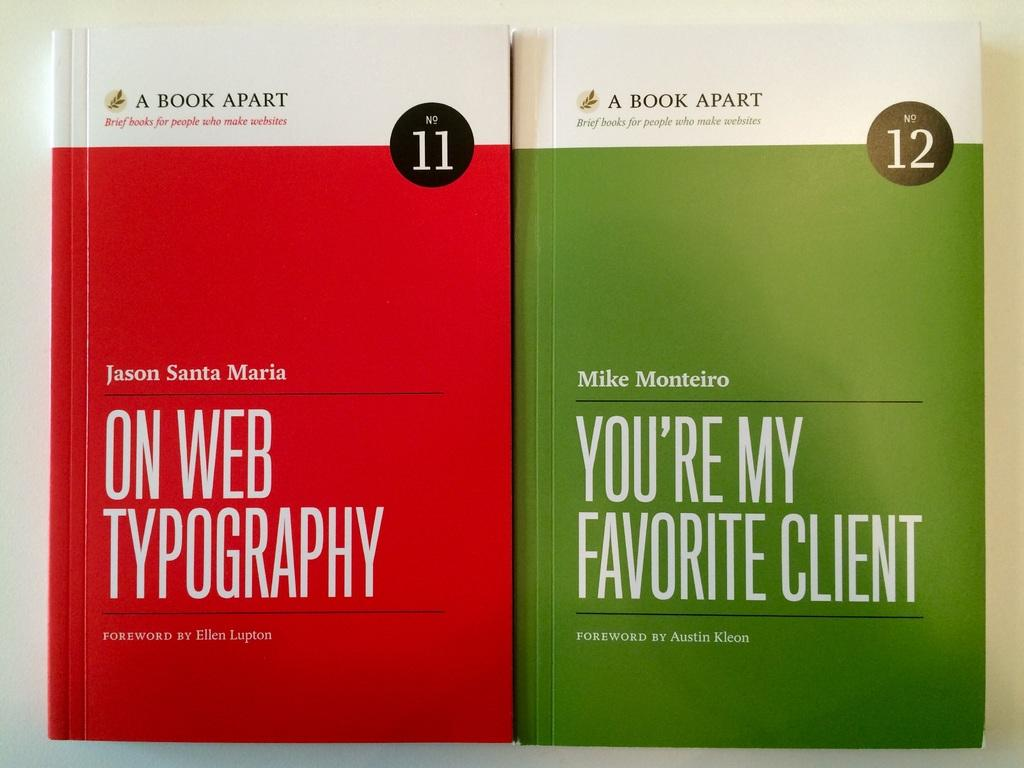<image>
Relay a brief, clear account of the picture shown. Jason Santa Maria On web typography book and you're my favorite client book by Mike Monteiro. 